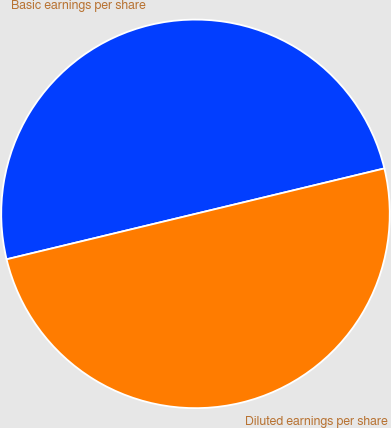<chart> <loc_0><loc_0><loc_500><loc_500><pie_chart><fcel>Basic earnings per share<fcel>Diluted earnings per share<nl><fcel>50.0%<fcel>50.0%<nl></chart> 